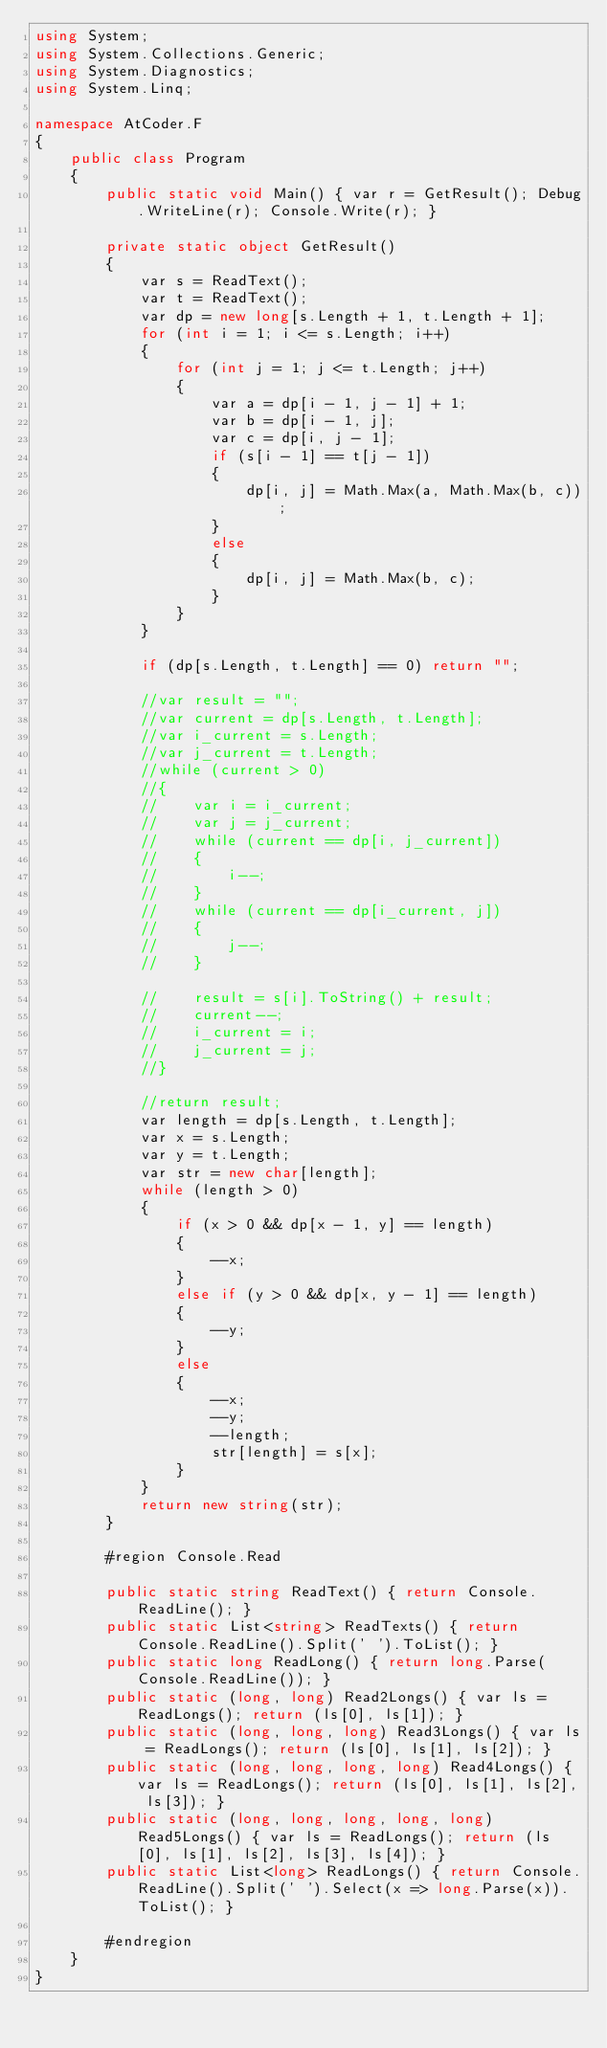<code> <loc_0><loc_0><loc_500><loc_500><_C#_>using System;
using System.Collections.Generic;
using System.Diagnostics;
using System.Linq;

namespace AtCoder.F
{
    public class Program
    {
        public static void Main() { var r = GetResult(); Debug.WriteLine(r); Console.Write(r); }

        private static object GetResult()
        {
            var s = ReadText();
            var t = ReadText();
            var dp = new long[s.Length + 1, t.Length + 1];
            for (int i = 1; i <= s.Length; i++)
            {
                for (int j = 1; j <= t.Length; j++)
                {
                    var a = dp[i - 1, j - 1] + 1;
                    var b = dp[i - 1, j];
                    var c = dp[i, j - 1];
                    if (s[i - 1] == t[j - 1])
                    {
                        dp[i, j] = Math.Max(a, Math.Max(b, c));
                    }
                    else
                    {
                        dp[i, j] = Math.Max(b, c);
                    }
                }
            }

            if (dp[s.Length, t.Length] == 0) return "";

            //var result = "";
            //var current = dp[s.Length, t.Length];
            //var i_current = s.Length;
            //var j_current = t.Length;
            //while (current > 0)
            //{
            //    var i = i_current;
            //    var j = j_current;
            //    while (current == dp[i, j_current])
            //    {
            //        i--;
            //    }
            //    while (current == dp[i_current, j])
            //    {
            //        j--;
            //    }

            //    result = s[i].ToString() + result;
            //    current--;
            //    i_current = i;
            //    j_current = j;
            //}

            //return result;
            var length = dp[s.Length, t.Length];
            var x = s.Length;
            var y = t.Length;
            var str = new char[length];
            while (length > 0)
            {
                if (x > 0 && dp[x - 1, y] == length)
                {
                    --x;
                }
                else if (y > 0 && dp[x, y - 1] == length)
                {
                    --y;
                }
                else
                {
                    --x;
                    --y;
                    --length;
                    str[length] = s[x];
                }
            }
            return new string(str);
        }

        #region Console.Read

        public static string ReadText() { return Console.ReadLine(); }
        public static List<string> ReadTexts() { return Console.ReadLine().Split(' ').ToList(); }
        public static long ReadLong() { return long.Parse(Console.ReadLine()); }
        public static (long, long) Read2Longs() { var ls = ReadLongs(); return (ls[0], ls[1]); }
        public static (long, long, long) Read3Longs() { var ls = ReadLongs(); return (ls[0], ls[1], ls[2]); }
        public static (long, long, long, long) Read4Longs() { var ls = ReadLongs(); return (ls[0], ls[1], ls[2], ls[3]); }
        public static (long, long, long, long, long) Read5Longs() { var ls = ReadLongs(); return (ls[0], ls[1], ls[2], ls[3], ls[4]); }
        public static List<long> ReadLongs() { return Console.ReadLine().Split(' ').Select(x => long.Parse(x)).ToList(); }

        #endregion
    }
}
</code> 